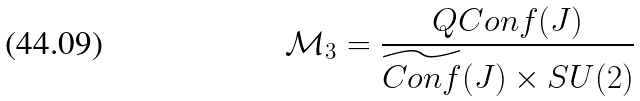Convert formula to latex. <formula><loc_0><loc_0><loc_500><loc_500>\mathcal { M } _ { 3 } = \frac { Q C o n f ( J ) } { \widetilde { C o n f } ( J ) \times S U ( 2 ) }</formula> 